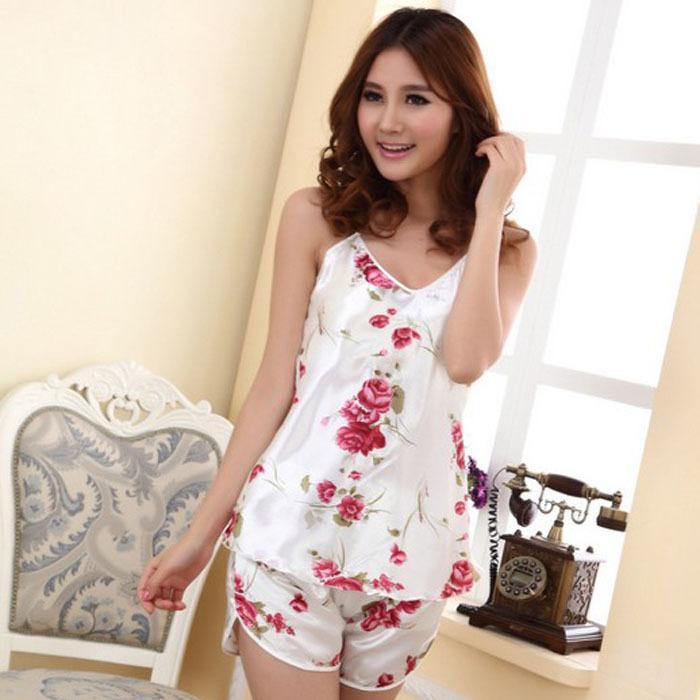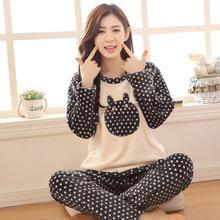The first image is the image on the left, the second image is the image on the right. For the images displayed, is the sentence "There is a lamp behind a girl wearing pajamas." factually correct? Answer yes or no. No. The first image is the image on the left, the second image is the image on the right. Considering the images on both sides, is "A model wears a pajama shorts set patterned all over with cute animals." valid? Answer yes or no. No. 